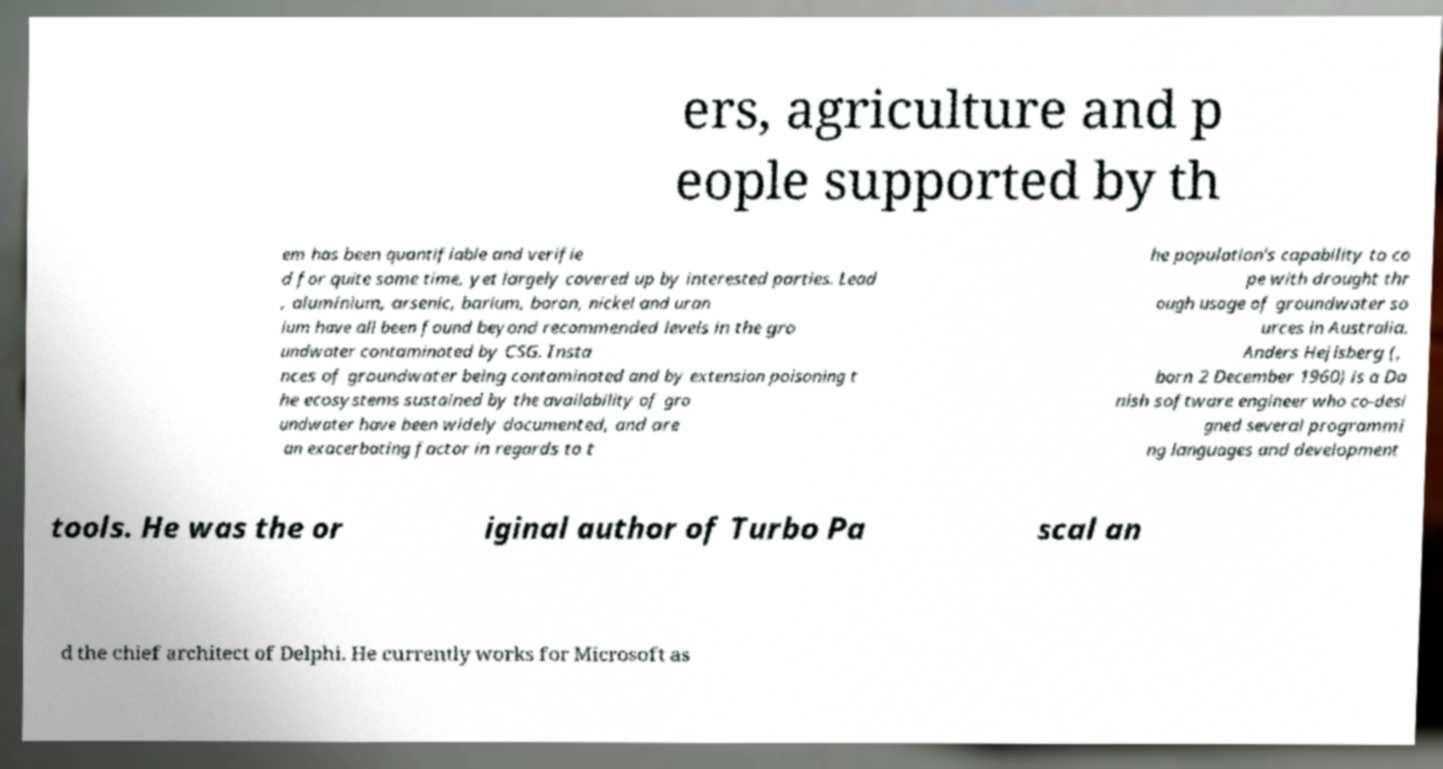Please identify and transcribe the text found in this image. ers, agriculture and p eople supported by th em has been quantifiable and verifie d for quite some time, yet largely covered up by interested parties. Lead , aluminium, arsenic, barium, boron, nickel and uran ium have all been found beyond recommended levels in the gro undwater contaminated by CSG. Insta nces of groundwater being contaminated and by extension poisoning t he ecosystems sustained by the availability of gro undwater have been widely documented, and are an exacerbating factor in regards to t he population's capability to co pe with drought thr ough usage of groundwater so urces in Australia. Anders Hejlsberg (, born 2 December 1960) is a Da nish software engineer who co-desi gned several programmi ng languages and development tools. He was the or iginal author of Turbo Pa scal an d the chief architect of Delphi. He currently works for Microsoft as 